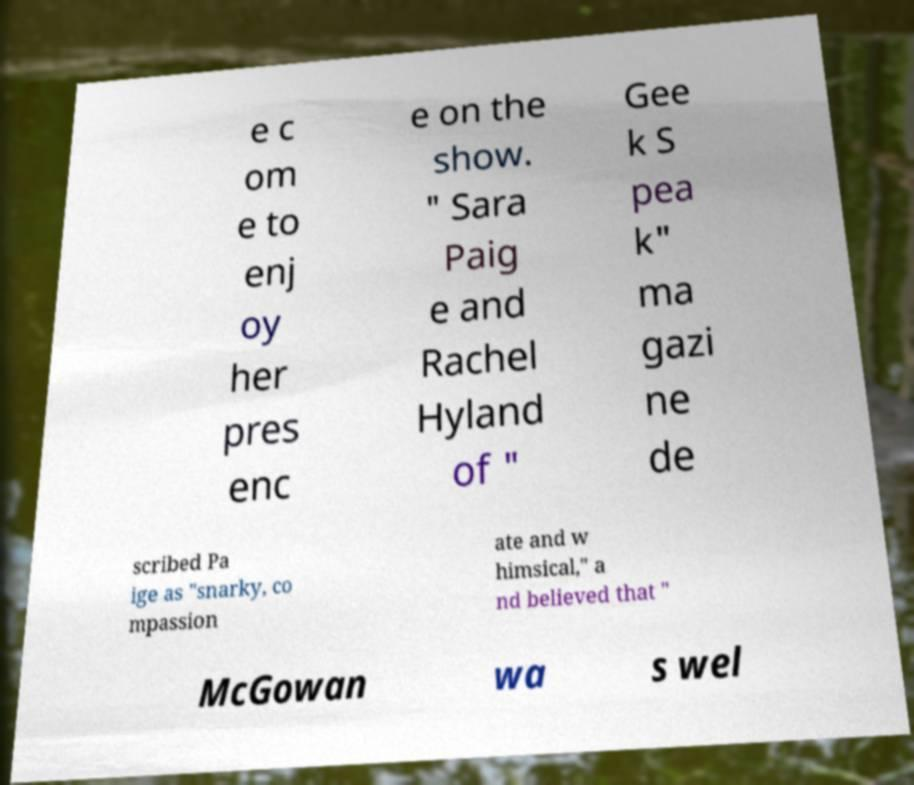Please identify and transcribe the text found in this image. e c om e to enj oy her pres enc e on the show. " Sara Paig e and Rachel Hyland of " Gee k S pea k" ma gazi ne de scribed Pa ige as "snarky, co mpassion ate and w himsical," a nd believed that " McGowan wa s wel 